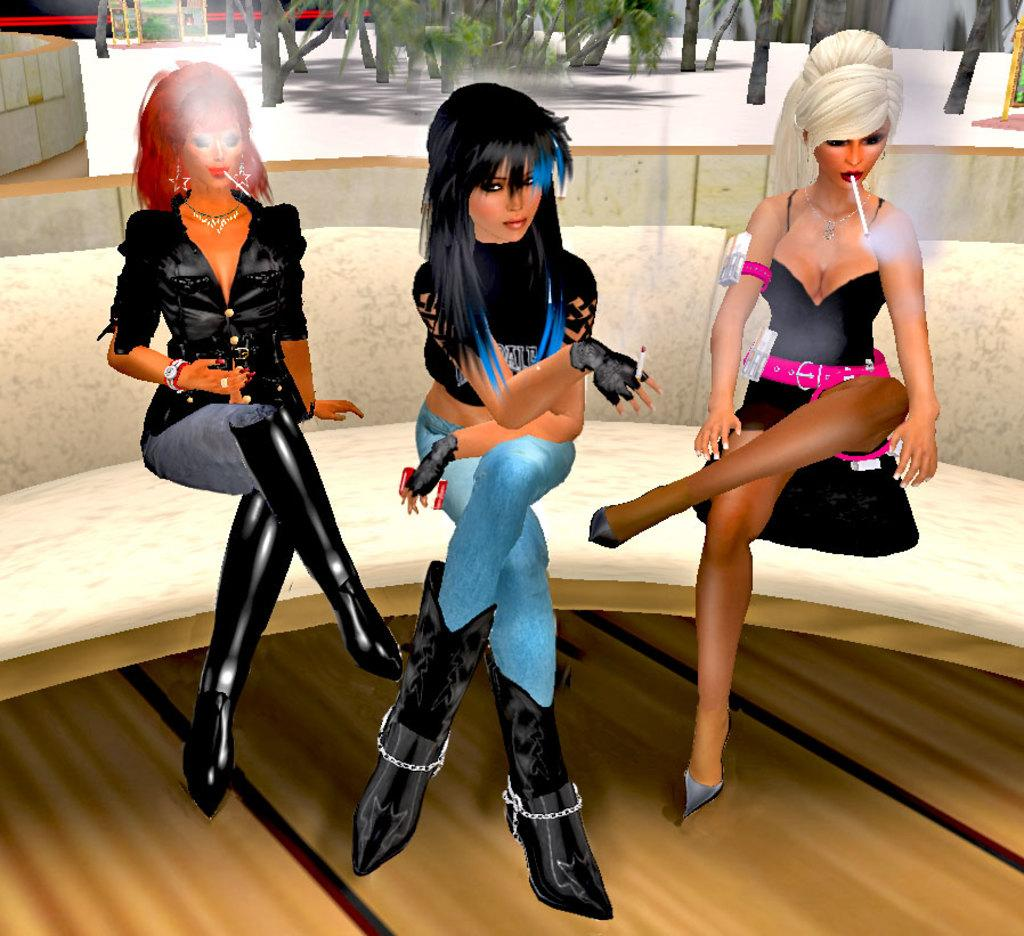What type of image is being described? The image is animated. How many women are present in the image? There are three women in the image. What are the women doing in the image? The women are sitting on a sofa. What can be seen in the background of the image? There are trees visible in the background of the image. What is the top skate rate in the image? There is no skate or rate mentioned in the image; it features three women sitting on a sofa in front of trees. 